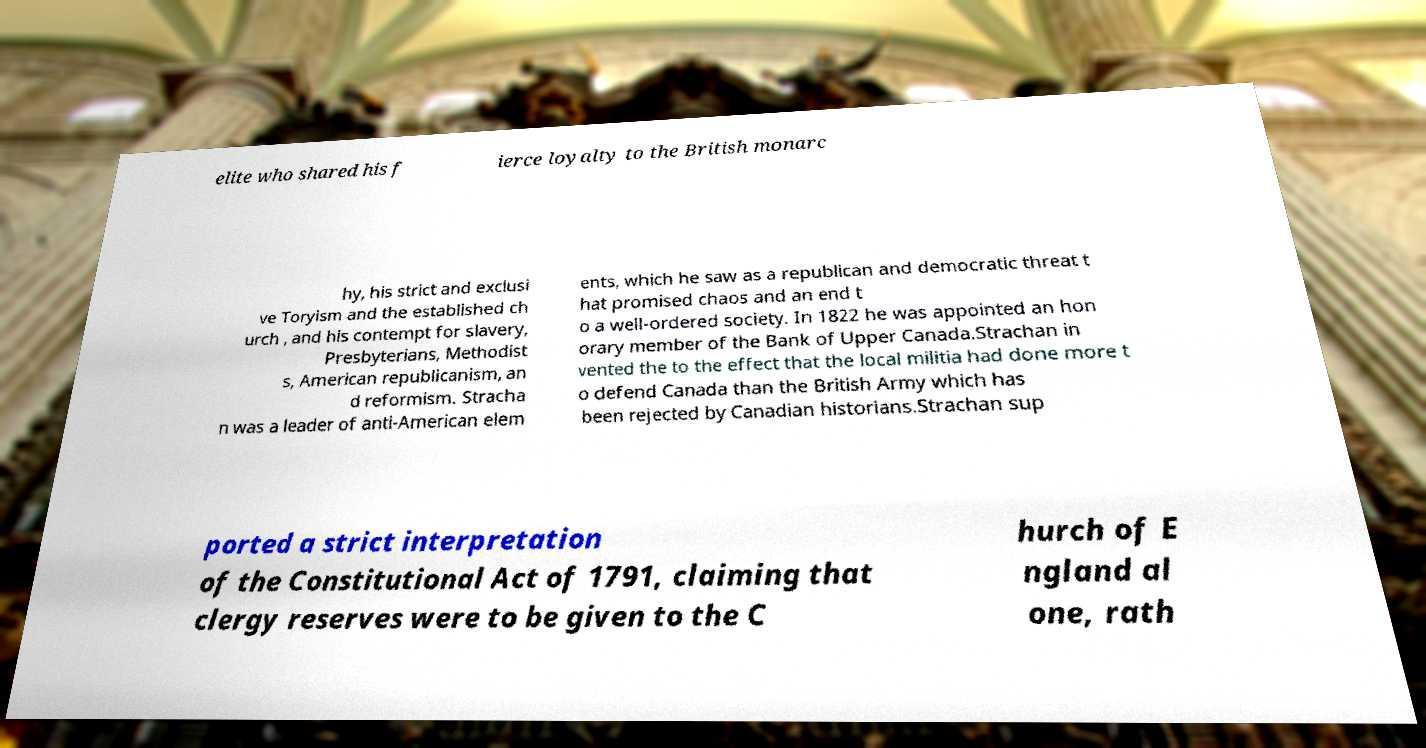There's text embedded in this image that I need extracted. Can you transcribe it verbatim? elite who shared his f ierce loyalty to the British monarc hy, his strict and exclusi ve Toryism and the established ch urch , and his contempt for slavery, Presbyterians, Methodist s, American republicanism, an d reformism. Stracha n was a leader of anti-American elem ents, which he saw as a republican and democratic threat t hat promised chaos and an end t o a well-ordered society. In 1822 he was appointed an hon orary member of the Bank of Upper Canada.Strachan in vented the to the effect that the local militia had done more t o defend Canada than the British Army which has been rejected by Canadian historians.Strachan sup ported a strict interpretation of the Constitutional Act of 1791, claiming that clergy reserves were to be given to the C hurch of E ngland al one, rath 